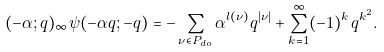Convert formula to latex. <formula><loc_0><loc_0><loc_500><loc_500>( - \alpha ; q ) _ { \infty } \psi ( - \alpha q ; - q ) = - \sum _ { \nu \in P _ { d o } } \alpha ^ { l ( \nu ) } q ^ { | \nu | } + \sum _ { k = 1 } ^ { \infty } ( - 1 ) ^ { k } q ^ { k ^ { 2 } } .</formula> 